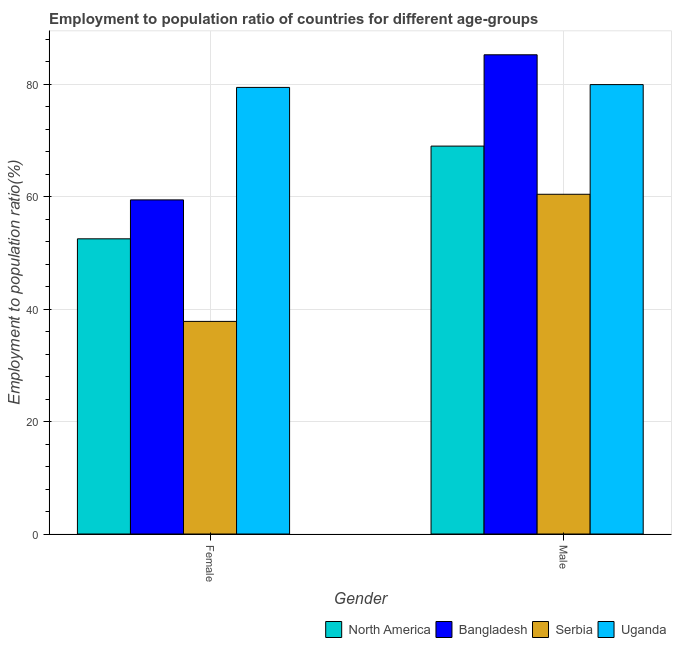How many different coloured bars are there?
Your answer should be very brief. 4. Are the number of bars per tick equal to the number of legend labels?
Give a very brief answer. Yes. How many bars are there on the 1st tick from the left?
Your response must be concise. 4. What is the employment to population ratio(female) in Serbia?
Provide a succinct answer. 37.8. Across all countries, what is the maximum employment to population ratio(male)?
Offer a terse response. 85.2. Across all countries, what is the minimum employment to population ratio(female)?
Give a very brief answer. 37.8. In which country was the employment to population ratio(male) maximum?
Keep it short and to the point. Bangladesh. In which country was the employment to population ratio(male) minimum?
Provide a succinct answer. Serbia. What is the total employment to population ratio(female) in the graph?
Keep it short and to the point. 229.08. What is the difference between the employment to population ratio(male) in Serbia and that in Bangladesh?
Provide a succinct answer. -24.8. What is the difference between the employment to population ratio(male) in Bangladesh and the employment to population ratio(female) in Serbia?
Keep it short and to the point. 47.4. What is the average employment to population ratio(female) per country?
Offer a very short reply. 57.27. What is the difference between the employment to population ratio(male) and employment to population ratio(female) in Serbia?
Your response must be concise. 22.6. In how many countries, is the employment to population ratio(female) greater than 32 %?
Keep it short and to the point. 4. What is the ratio of the employment to population ratio(male) in North America to that in Bangladesh?
Make the answer very short. 0.81. Is the employment to population ratio(male) in North America less than that in Bangladesh?
Provide a short and direct response. Yes. In how many countries, is the employment to population ratio(female) greater than the average employment to population ratio(female) taken over all countries?
Your answer should be compact. 2. What does the 3rd bar from the left in Male represents?
Your answer should be compact. Serbia. What does the 2nd bar from the right in Male represents?
Your answer should be very brief. Serbia. How many bars are there?
Keep it short and to the point. 8. How many countries are there in the graph?
Ensure brevity in your answer.  4. What is the difference between two consecutive major ticks on the Y-axis?
Offer a very short reply. 20. Are the values on the major ticks of Y-axis written in scientific E-notation?
Ensure brevity in your answer.  No. Does the graph contain grids?
Offer a very short reply. Yes. Where does the legend appear in the graph?
Offer a very short reply. Bottom right. How many legend labels are there?
Make the answer very short. 4. What is the title of the graph?
Give a very brief answer. Employment to population ratio of countries for different age-groups. Does "Uzbekistan" appear as one of the legend labels in the graph?
Your answer should be compact. No. What is the label or title of the Y-axis?
Offer a very short reply. Employment to population ratio(%). What is the Employment to population ratio(%) of North America in Female?
Your response must be concise. 52.48. What is the Employment to population ratio(%) in Bangladesh in Female?
Offer a very short reply. 59.4. What is the Employment to population ratio(%) in Serbia in Female?
Your answer should be very brief. 37.8. What is the Employment to population ratio(%) of Uganda in Female?
Your answer should be very brief. 79.4. What is the Employment to population ratio(%) in North America in Male?
Your response must be concise. 68.96. What is the Employment to population ratio(%) of Bangladesh in Male?
Offer a very short reply. 85.2. What is the Employment to population ratio(%) of Serbia in Male?
Provide a short and direct response. 60.4. What is the Employment to population ratio(%) of Uganda in Male?
Provide a succinct answer. 79.9. Across all Gender, what is the maximum Employment to population ratio(%) in North America?
Your response must be concise. 68.96. Across all Gender, what is the maximum Employment to population ratio(%) in Bangladesh?
Your answer should be very brief. 85.2. Across all Gender, what is the maximum Employment to population ratio(%) of Serbia?
Keep it short and to the point. 60.4. Across all Gender, what is the maximum Employment to population ratio(%) in Uganda?
Your answer should be compact. 79.9. Across all Gender, what is the minimum Employment to population ratio(%) of North America?
Ensure brevity in your answer.  52.48. Across all Gender, what is the minimum Employment to population ratio(%) of Bangladesh?
Provide a succinct answer. 59.4. Across all Gender, what is the minimum Employment to population ratio(%) in Serbia?
Make the answer very short. 37.8. Across all Gender, what is the minimum Employment to population ratio(%) in Uganda?
Give a very brief answer. 79.4. What is the total Employment to population ratio(%) of North America in the graph?
Give a very brief answer. 121.44. What is the total Employment to population ratio(%) in Bangladesh in the graph?
Keep it short and to the point. 144.6. What is the total Employment to population ratio(%) in Serbia in the graph?
Your response must be concise. 98.2. What is the total Employment to population ratio(%) of Uganda in the graph?
Offer a very short reply. 159.3. What is the difference between the Employment to population ratio(%) of North America in Female and that in Male?
Provide a short and direct response. -16.48. What is the difference between the Employment to population ratio(%) in Bangladesh in Female and that in Male?
Your answer should be compact. -25.8. What is the difference between the Employment to population ratio(%) of Serbia in Female and that in Male?
Provide a short and direct response. -22.6. What is the difference between the Employment to population ratio(%) in North America in Female and the Employment to population ratio(%) in Bangladesh in Male?
Your answer should be very brief. -32.72. What is the difference between the Employment to population ratio(%) of North America in Female and the Employment to population ratio(%) of Serbia in Male?
Offer a terse response. -7.92. What is the difference between the Employment to population ratio(%) in North America in Female and the Employment to population ratio(%) in Uganda in Male?
Make the answer very short. -27.42. What is the difference between the Employment to population ratio(%) of Bangladesh in Female and the Employment to population ratio(%) of Uganda in Male?
Give a very brief answer. -20.5. What is the difference between the Employment to population ratio(%) of Serbia in Female and the Employment to population ratio(%) of Uganda in Male?
Your response must be concise. -42.1. What is the average Employment to population ratio(%) of North America per Gender?
Ensure brevity in your answer.  60.72. What is the average Employment to population ratio(%) of Bangladesh per Gender?
Offer a very short reply. 72.3. What is the average Employment to population ratio(%) of Serbia per Gender?
Make the answer very short. 49.1. What is the average Employment to population ratio(%) in Uganda per Gender?
Your response must be concise. 79.65. What is the difference between the Employment to population ratio(%) of North America and Employment to population ratio(%) of Bangladesh in Female?
Ensure brevity in your answer.  -6.92. What is the difference between the Employment to population ratio(%) of North America and Employment to population ratio(%) of Serbia in Female?
Provide a succinct answer. 14.68. What is the difference between the Employment to population ratio(%) of North America and Employment to population ratio(%) of Uganda in Female?
Your response must be concise. -26.92. What is the difference between the Employment to population ratio(%) in Bangladesh and Employment to population ratio(%) in Serbia in Female?
Your answer should be very brief. 21.6. What is the difference between the Employment to population ratio(%) in Serbia and Employment to population ratio(%) in Uganda in Female?
Offer a terse response. -41.6. What is the difference between the Employment to population ratio(%) of North America and Employment to population ratio(%) of Bangladesh in Male?
Ensure brevity in your answer.  -16.24. What is the difference between the Employment to population ratio(%) of North America and Employment to population ratio(%) of Serbia in Male?
Give a very brief answer. 8.56. What is the difference between the Employment to population ratio(%) of North America and Employment to population ratio(%) of Uganda in Male?
Ensure brevity in your answer.  -10.94. What is the difference between the Employment to population ratio(%) of Bangladesh and Employment to population ratio(%) of Serbia in Male?
Offer a very short reply. 24.8. What is the difference between the Employment to population ratio(%) in Serbia and Employment to population ratio(%) in Uganda in Male?
Your response must be concise. -19.5. What is the ratio of the Employment to population ratio(%) of North America in Female to that in Male?
Keep it short and to the point. 0.76. What is the ratio of the Employment to population ratio(%) in Bangladesh in Female to that in Male?
Offer a very short reply. 0.7. What is the ratio of the Employment to population ratio(%) of Serbia in Female to that in Male?
Provide a short and direct response. 0.63. What is the ratio of the Employment to population ratio(%) of Uganda in Female to that in Male?
Your answer should be compact. 0.99. What is the difference between the highest and the second highest Employment to population ratio(%) of North America?
Give a very brief answer. 16.48. What is the difference between the highest and the second highest Employment to population ratio(%) in Bangladesh?
Make the answer very short. 25.8. What is the difference between the highest and the second highest Employment to population ratio(%) in Serbia?
Keep it short and to the point. 22.6. What is the difference between the highest and the lowest Employment to population ratio(%) in North America?
Give a very brief answer. 16.48. What is the difference between the highest and the lowest Employment to population ratio(%) of Bangladesh?
Give a very brief answer. 25.8. What is the difference between the highest and the lowest Employment to population ratio(%) in Serbia?
Offer a terse response. 22.6. What is the difference between the highest and the lowest Employment to population ratio(%) of Uganda?
Your answer should be very brief. 0.5. 